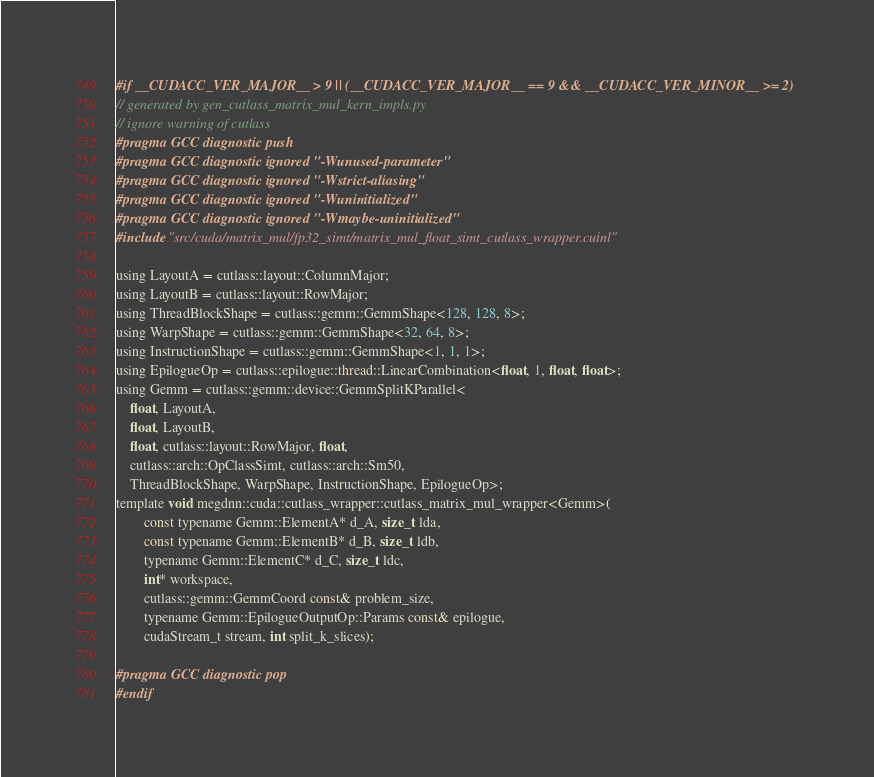<code> <loc_0><loc_0><loc_500><loc_500><_Cuda_>#if __CUDACC_VER_MAJOR__ > 9 || (__CUDACC_VER_MAJOR__ == 9 && __CUDACC_VER_MINOR__ >= 2)
// generated by gen_cutlass_matrix_mul_kern_impls.py
// ignore warning of cutlass
#pragma GCC diagnostic push
#pragma GCC diagnostic ignored "-Wunused-parameter"
#pragma GCC diagnostic ignored "-Wstrict-aliasing"
#pragma GCC diagnostic ignored "-Wuninitialized"
#pragma GCC diagnostic ignored "-Wmaybe-uninitialized"
#include "src/cuda/matrix_mul/fp32_simt/matrix_mul_float_simt_cutlass_wrapper.cuinl"

using LayoutA = cutlass::layout::ColumnMajor;
using LayoutB = cutlass::layout::RowMajor;
using ThreadBlockShape = cutlass::gemm::GemmShape<128, 128, 8>;
using WarpShape = cutlass::gemm::GemmShape<32, 64, 8>;
using InstructionShape = cutlass::gemm::GemmShape<1, 1, 1>;
using EpilogueOp = cutlass::epilogue::thread::LinearCombination<float, 1, float, float>;
using Gemm = cutlass::gemm::device::GemmSplitKParallel<
    float, LayoutA, 
    float, LayoutB, 
    float, cutlass::layout::RowMajor, float, 
    cutlass::arch::OpClassSimt, cutlass::arch::Sm50, 
    ThreadBlockShape, WarpShape, InstructionShape, EpilogueOp>;
template void megdnn::cuda::cutlass_wrapper::cutlass_matrix_mul_wrapper<Gemm>(
        const typename Gemm::ElementA* d_A, size_t lda, 
        const typename Gemm::ElementB* d_B, size_t ldb,  
        typename Gemm::ElementC* d_C, size_t ldc,  
        int* workspace, 
        cutlass::gemm::GemmCoord const& problem_size,   
        typename Gemm::EpilogueOutputOp::Params const& epilogue, 
        cudaStream_t stream, int split_k_slices);

#pragma GCC diagnostic pop
#endif
</code> 